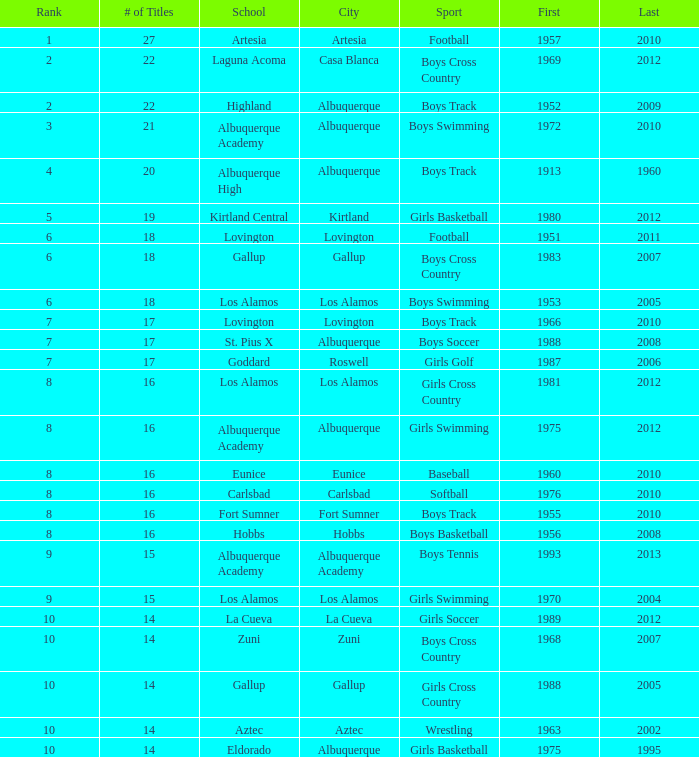Where is the school with under 17 boys basketball titles, if the last championship was won after the year 2005? Hobbs. 